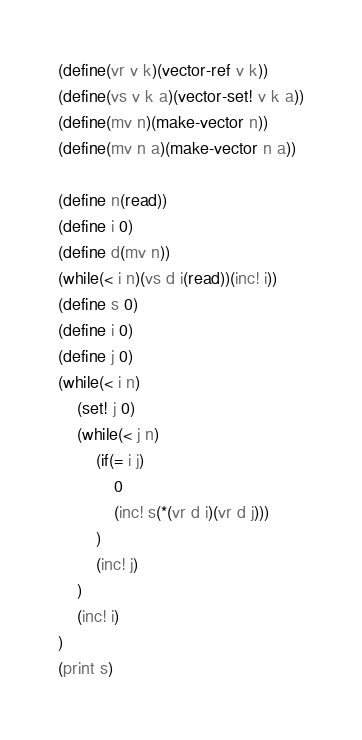Convert code to text. <code><loc_0><loc_0><loc_500><loc_500><_Scheme_>(define(vr v k)(vector-ref v k))
(define(vs v k a)(vector-set! v k a))
(define(mv n)(make-vector n))
(define(mv n a)(make-vector n a))

(define n(read))
(define i 0)
(define d(mv n))
(while(< i n)(vs d i(read))(inc! i))
(define s 0)
(define i 0)
(define j 0)
(while(< i n)
	(set! j 0)
	(while(< j n)
		(if(= i j)
			0
			(inc! s(*(vr d i)(vr d j)))
		)
		(inc! j)
	)
	(inc! i)
)
(print s)</code> 